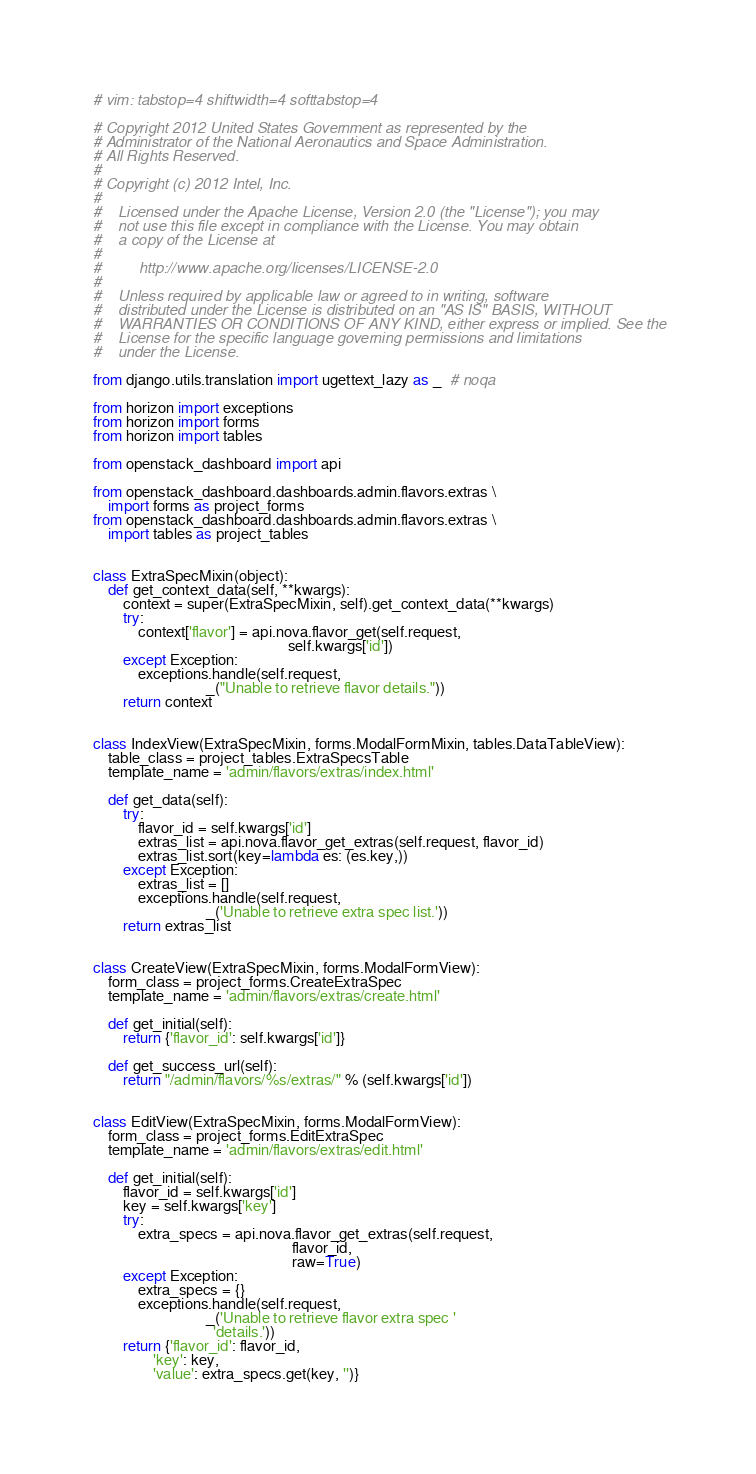<code> <loc_0><loc_0><loc_500><loc_500><_Python_># vim: tabstop=4 shiftwidth=4 softtabstop=4

# Copyright 2012 United States Government as represented by the
# Administrator of the National Aeronautics and Space Administration.
# All Rights Reserved.
#
# Copyright (c) 2012 Intel, Inc.
#
#    Licensed under the Apache License, Version 2.0 (the "License"); you may
#    not use this file except in compliance with the License. You may obtain
#    a copy of the License at
#
#         http://www.apache.org/licenses/LICENSE-2.0
#
#    Unless required by applicable law or agreed to in writing, software
#    distributed under the License is distributed on an "AS IS" BASIS, WITHOUT
#    WARRANTIES OR CONDITIONS OF ANY KIND, either express or implied. See the
#    License for the specific language governing permissions and limitations
#    under the License.

from django.utils.translation import ugettext_lazy as _  # noqa

from horizon import exceptions
from horizon import forms
from horizon import tables

from openstack_dashboard import api

from openstack_dashboard.dashboards.admin.flavors.extras \
    import forms as project_forms
from openstack_dashboard.dashboards.admin.flavors.extras \
    import tables as project_tables


class ExtraSpecMixin(object):
    def get_context_data(self, **kwargs):
        context = super(ExtraSpecMixin, self).get_context_data(**kwargs)
        try:
            context['flavor'] = api.nova.flavor_get(self.request,
                                                    self.kwargs['id'])
        except Exception:
            exceptions.handle(self.request,
                              _("Unable to retrieve flavor details."))
        return context


class IndexView(ExtraSpecMixin, forms.ModalFormMixin, tables.DataTableView):
    table_class = project_tables.ExtraSpecsTable
    template_name = 'admin/flavors/extras/index.html'

    def get_data(self):
        try:
            flavor_id = self.kwargs['id']
            extras_list = api.nova.flavor_get_extras(self.request, flavor_id)
            extras_list.sort(key=lambda es: (es.key,))
        except Exception:
            extras_list = []
            exceptions.handle(self.request,
                              _('Unable to retrieve extra spec list.'))
        return extras_list


class CreateView(ExtraSpecMixin, forms.ModalFormView):
    form_class = project_forms.CreateExtraSpec
    template_name = 'admin/flavors/extras/create.html'

    def get_initial(self):
        return {'flavor_id': self.kwargs['id']}

    def get_success_url(self):
        return "/admin/flavors/%s/extras/" % (self.kwargs['id'])


class EditView(ExtraSpecMixin, forms.ModalFormView):
    form_class = project_forms.EditExtraSpec
    template_name = 'admin/flavors/extras/edit.html'

    def get_initial(self):
        flavor_id = self.kwargs['id']
        key = self.kwargs['key']
        try:
            extra_specs = api.nova.flavor_get_extras(self.request,
                                                     flavor_id,
                                                     raw=True)
        except Exception:
            extra_specs = {}
            exceptions.handle(self.request,
                              _('Unable to retrieve flavor extra spec '
                                'details.'))
        return {'flavor_id': flavor_id,
                'key': key,
                'value': extra_specs.get(key, '')}
</code> 